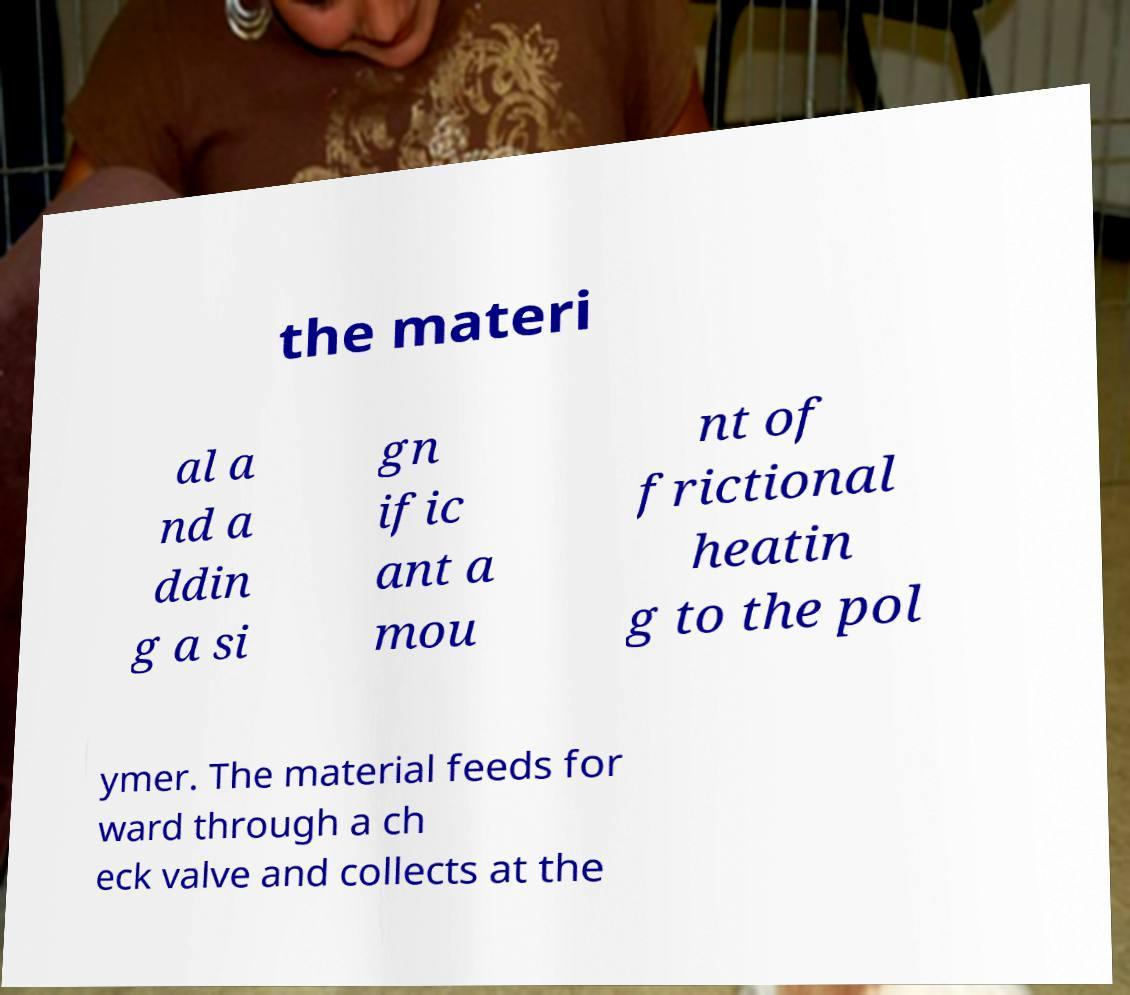Could you assist in decoding the text presented in this image and type it out clearly? the materi al a nd a ddin g a si gn ific ant a mou nt of frictional heatin g to the pol ymer. The material feeds for ward through a ch eck valve and collects at the 